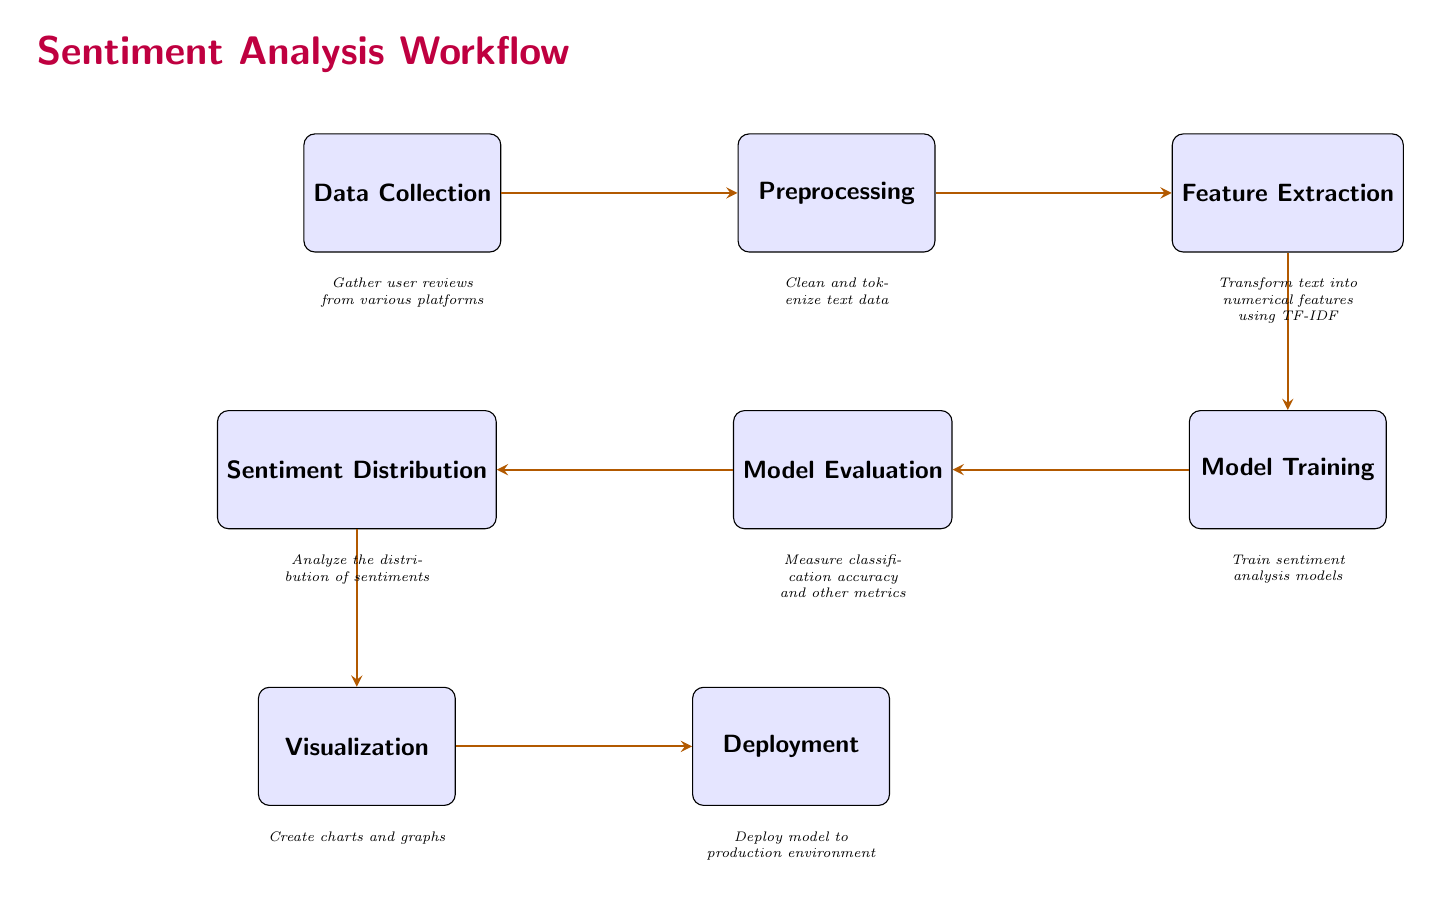What is the first step in the sentiment analysis workflow? The first step, indicated by the leftmost box in the diagram, is "Data Collection," which gathers user reviews.
Answer: Data Collection How many nodes are present in this diagram? The diagram includes a total of eight nodes, each representing a step in the sentiment analysis workflow.
Answer: Eight What is analyzed after model evaluation? The sentiment distribution is analyzed after the evaluation step, as indicated by the downward arrow leading from evaluation to sentiment distribution.
Answer: Sentiment Distribution Which step transforms text into numerical features? The "Feature Extraction" step is responsible for transforming text data into numerical features, as it is directly connected to the preprocessing step.
Answer: Feature Extraction What follows the visualization step? The "Deployment" step follows the visualization step, as shown by the arrow leading to the right.
Answer: Deployment What does the evaluation step measure? The evaluation step measures classification accuracy and other metrics, as noted in the description below the evaluation node.
Answer: Classification accuracy How many edges are there in the diagram? There are seven edges connecting the eight nodes in the diagram, indicating the sequential flow of the sentiment analysis process.
Answer: Seven What does the sentiment distribution result lead to? The output of the sentiment distribution leads to the visualization step, illustrating that sentiment analysis results are visualized for better understanding.
Answer: Visualization What is the result of feature extraction? The result of feature extraction is numerical features created using the TF-IDF method, as detailed in the description for that node.
Answer: Numerical features 